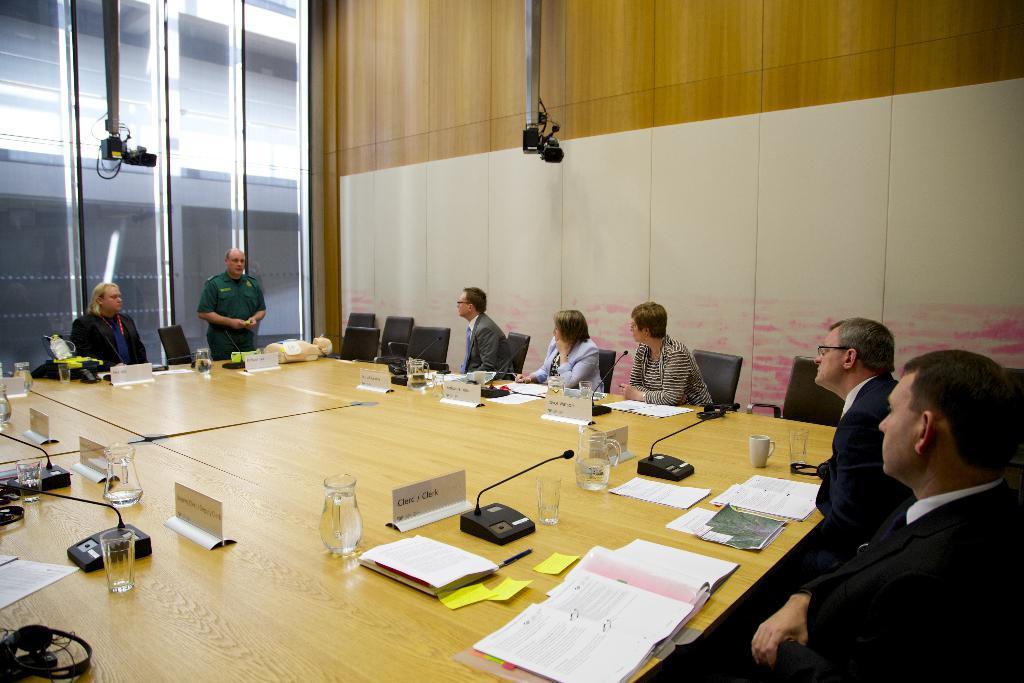Can you describe this image briefly? This Image is clicked in room. There are so many tables and chairs in this room. On tables there are jars, glasses, name boards, papers, books, cups. There are people sitting in chairs around the table. 